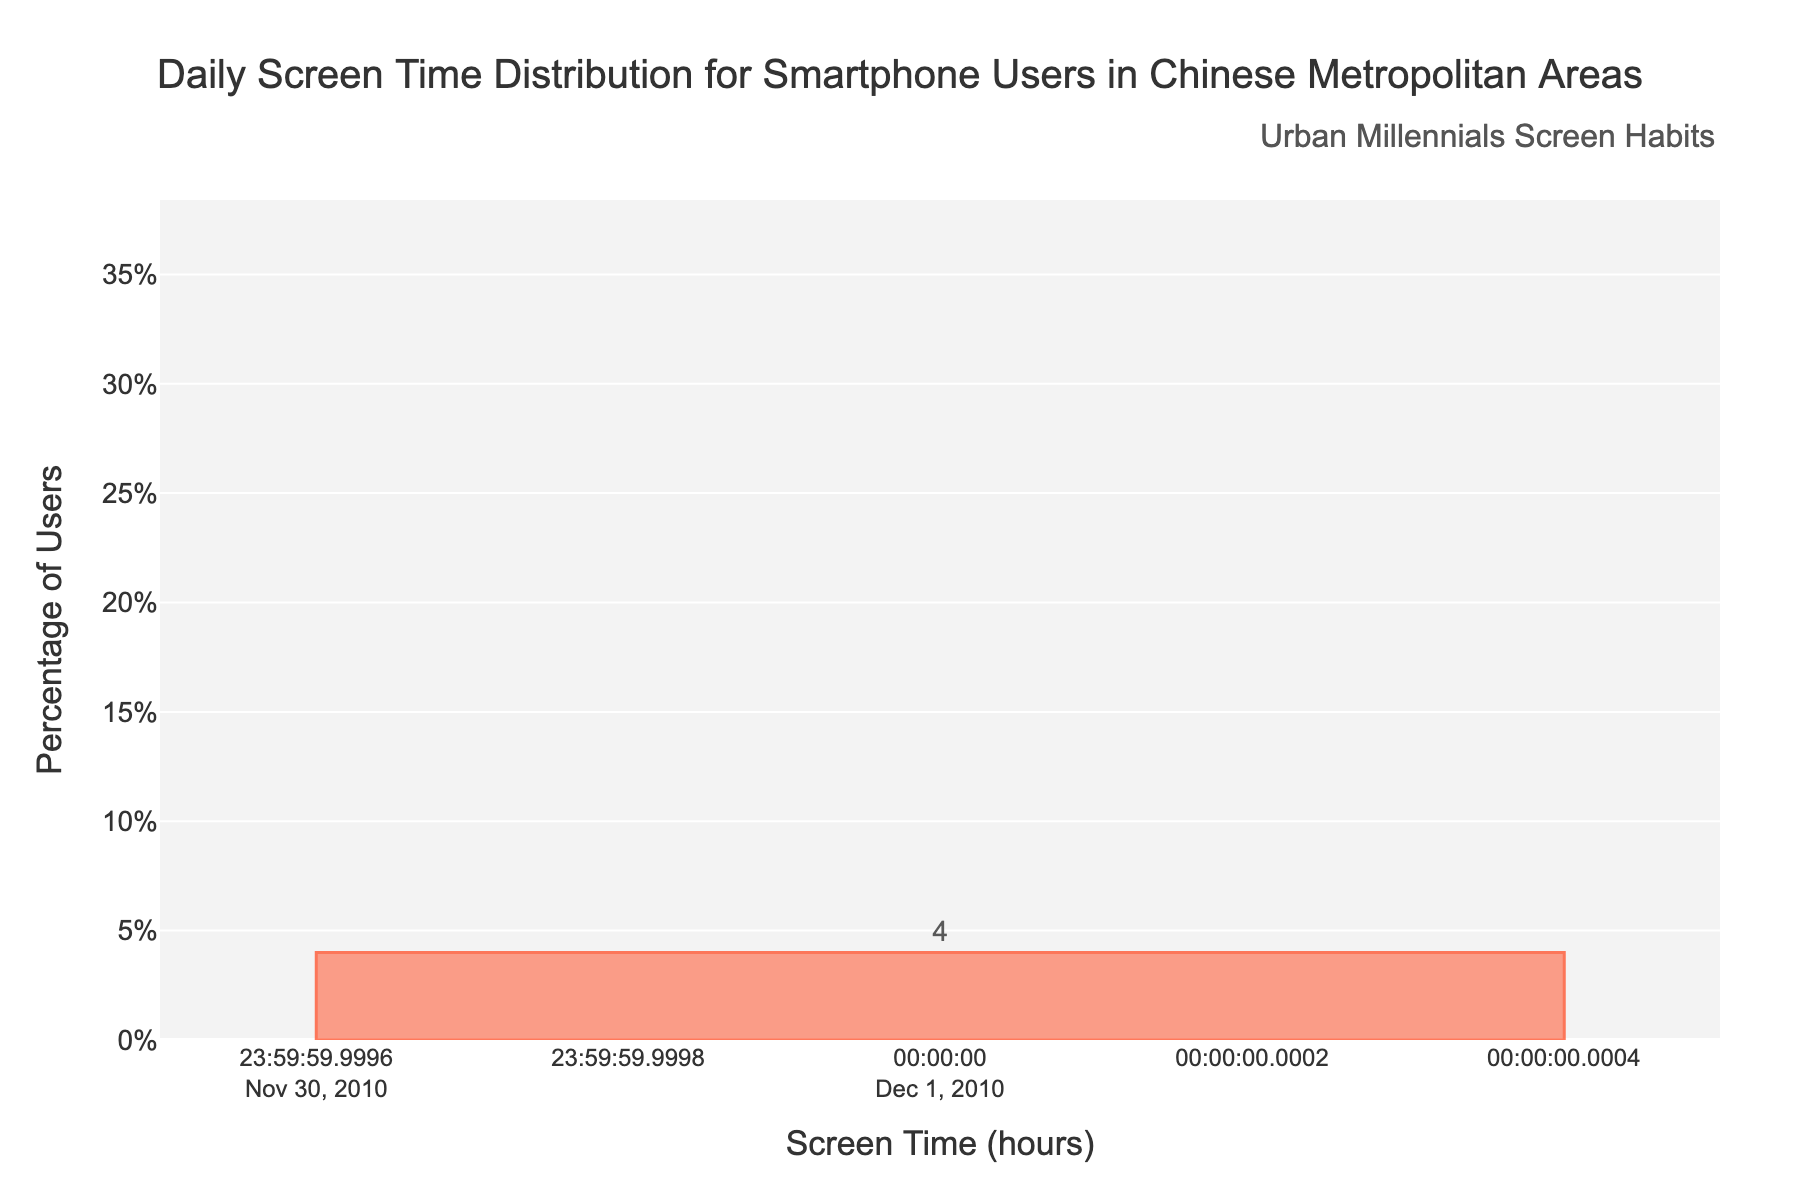What's the percentage of users with a daily screen time of 6-8 hours? Locate the bar labeled "6-8 hours" on the x-axis, and check the y-axis value for this bar, which represents the percentage. The value is 32.
Answer: 32% Which screen time bracket has the highest percentage of users? Identify the bar that reaches the highest point on the y-axis. This bar represents the "6-8 hours" bracket.
Answer: 6-8 hours What is the total percentage of users who spend 8 or more hours on their smartphones daily? Sum the percentages of the "8-10 hours," "10-12 hours," and "12+ hours" brackets. The values are 12, 4, and 1 respectively. Adding them gives 12 + 4 + 1 = 17.
Answer: 17% How does the percentage of users in the 4-6 hours bracket compare to those in the 2-4 hours bracket? Compare the y-axis values for the "4-6 hours" and "2-4 hours" brackets. The values are 28% and 15% respectively. 28% is greater than 15%.
Answer: More users in the 4-6 hours bracket What is the median screen time bracket? The median is the middle value when the data points are ordered. The ordered percentages are 1, 4, 8, 12, 15, 28, 32. The middle value is in the "4-6 hours" bracket.
Answer: 4-6 hours What percentage of users has a screen time of less than 4 hours daily? Sum the percentages of the "0-2 hours" and "2-4 hours" brackets. The values are 8 and 15 respectively. Adding them gives 8 + 15 = 23.
Answer: 23% Is the screen time distribution positively or negatively skewed? Positive skew means most of the data points are concentrated on the left side with a long tail on the right. The histogram shows more users in the lower screen time brackets and fewer in the higher ones.
Answer: Positively skewed How many hours do the majority of users spend on their smartphones daily? Identify the screen time bracket with the highest percentage. The "6-8 hours" bracket has the highest percentage of 32%.
Answer: 6-8 hours What is the range of screen time hours that covers at least 50% of users? Identify adjacent brackets whose cumulative percentage is at least 50%. Adding "4-6 hours" (28%) and "6-8 hours" (32%) equals 60%, which covers at least 50%.
Answer: 4-8 hours 